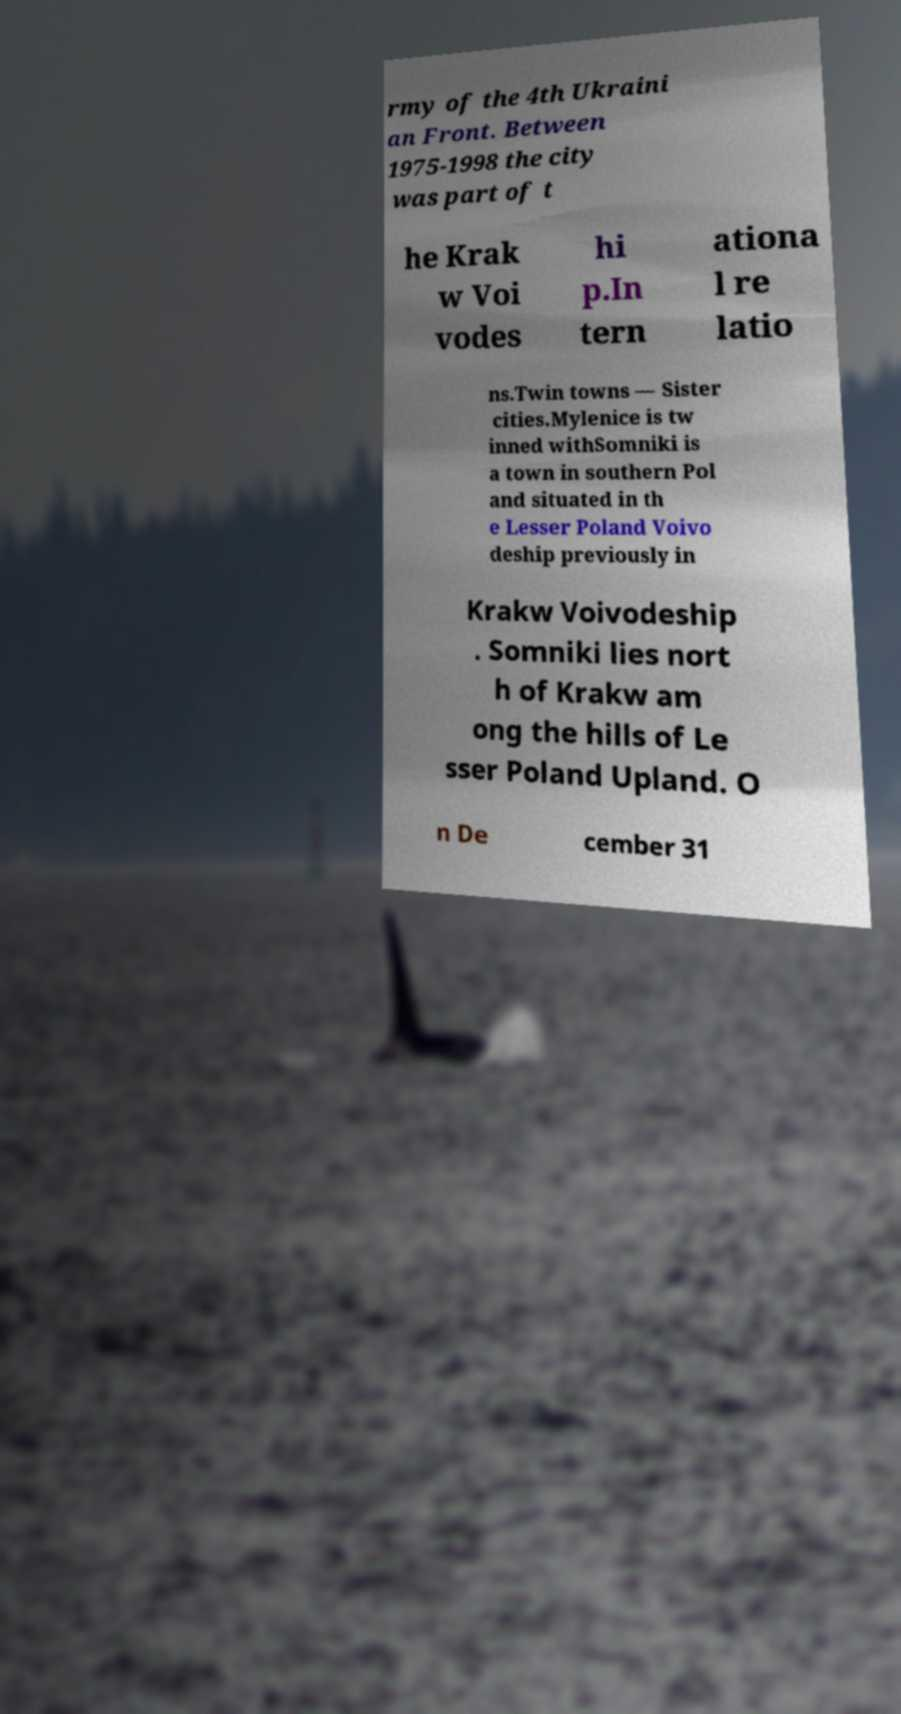There's text embedded in this image that I need extracted. Can you transcribe it verbatim? rmy of the 4th Ukraini an Front. Between 1975-1998 the city was part of t he Krak w Voi vodes hi p.In tern ationa l re latio ns.Twin towns — Sister cities.Mylenice is tw inned withSomniki is a town in southern Pol and situated in th e Lesser Poland Voivo deship previously in Krakw Voivodeship . Somniki lies nort h of Krakw am ong the hills of Le sser Poland Upland. O n De cember 31 